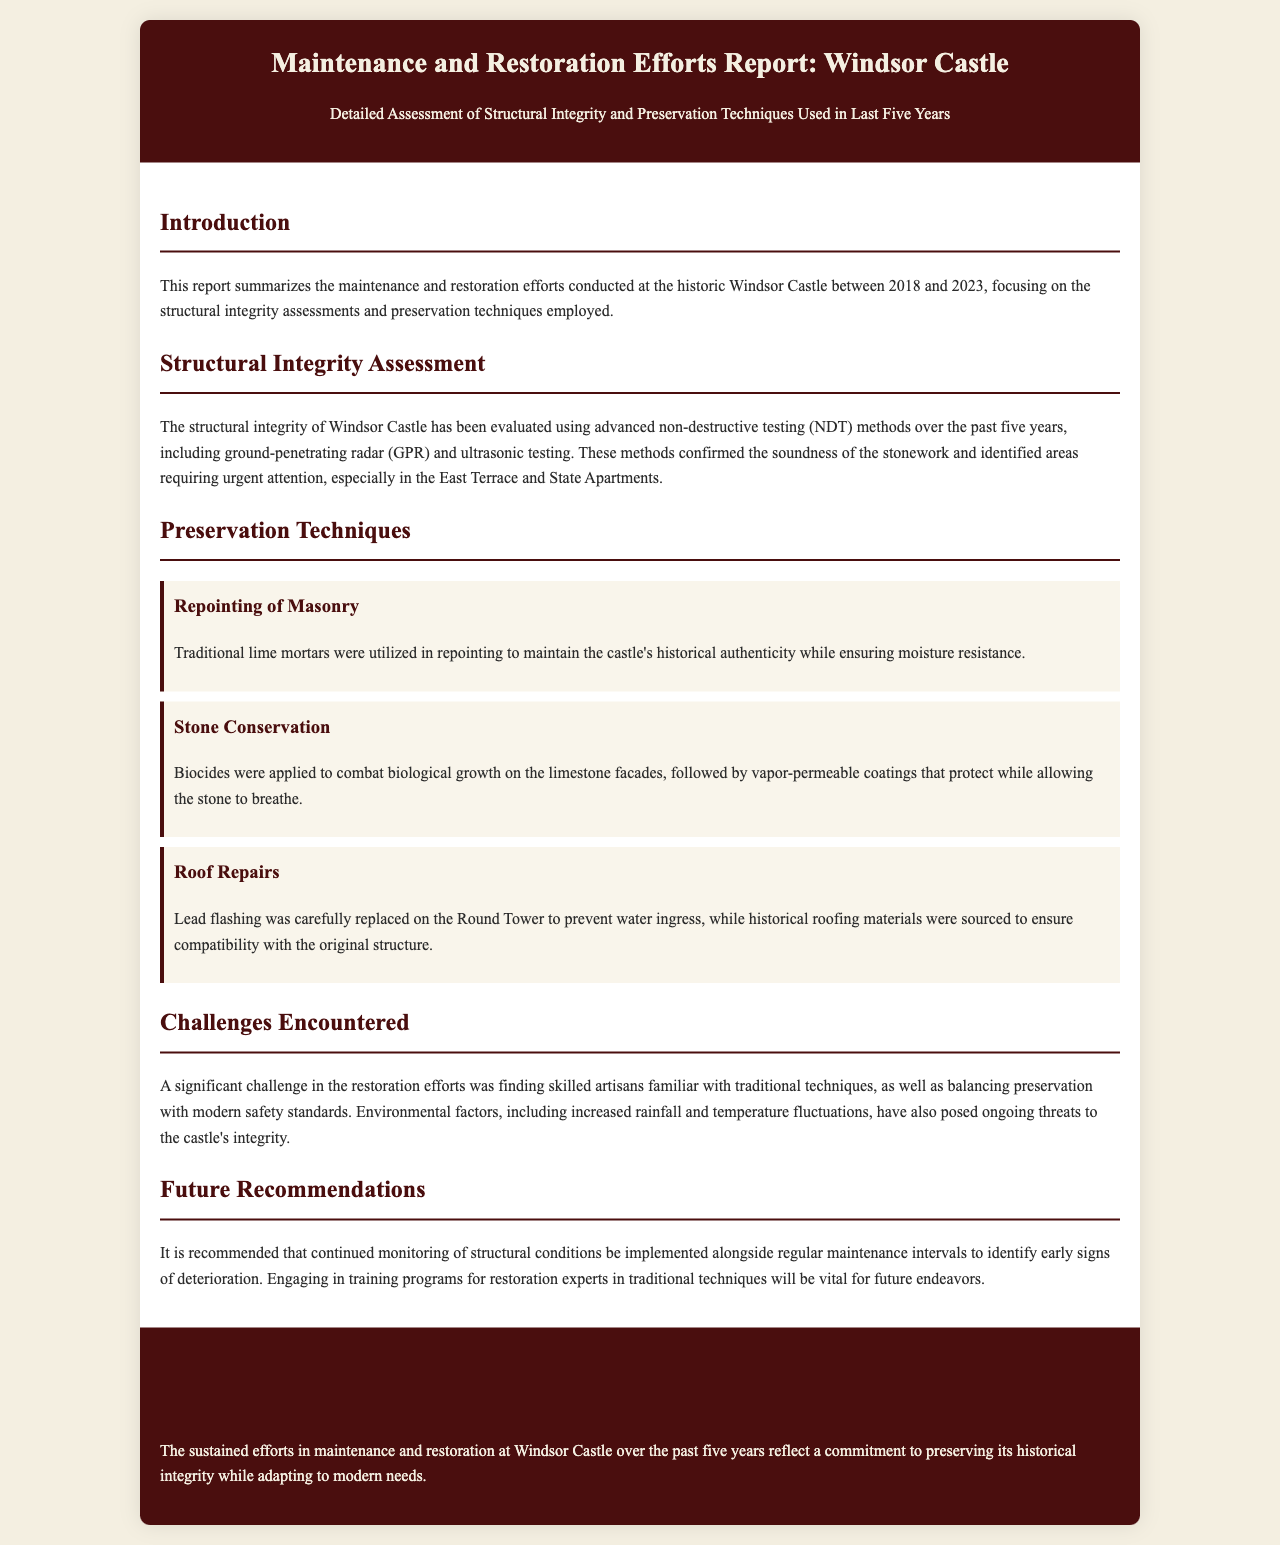What is the timeframe covered in the report? The report covers the maintenance and restoration efforts conducted at Windsor Castle between 2018 and 2023.
Answer: 2018 to 2023 What is one method used for structural integrity assessment? The document mentions that ground-penetrating radar (GPR) is one of the advanced non-destructive testing methods used.
Answer: Ground-penetrating radar Which area required urgent attention during the assessments? The document specifies that urgent attention was needed in the East Terrace and State Apartments.
Answer: East Terrace and State Apartments What technique was used for stone conservation? The report states that biocides were applied to combat biological growth on the limestone facades.
Answer: Biocides What was a challenge faced during the restoration efforts? The document notes that finding skilled artisans familiar with traditional techniques was a significant challenge.
Answer: Finding skilled artisans What type of mortar was used in repointing? The report indicates that traditional lime mortars were used in repointing.
Answer: Traditional lime mortars What is a future recommendation mentioned in the report? The report recommends engaging in training programs for restoration experts in traditional techniques.
Answer: Training programs for restoration experts What material was replaced on the Round Tower to prevent water ingress? According to the document, lead flashing was replaced on the Round Tower.
Answer: Lead flashing 